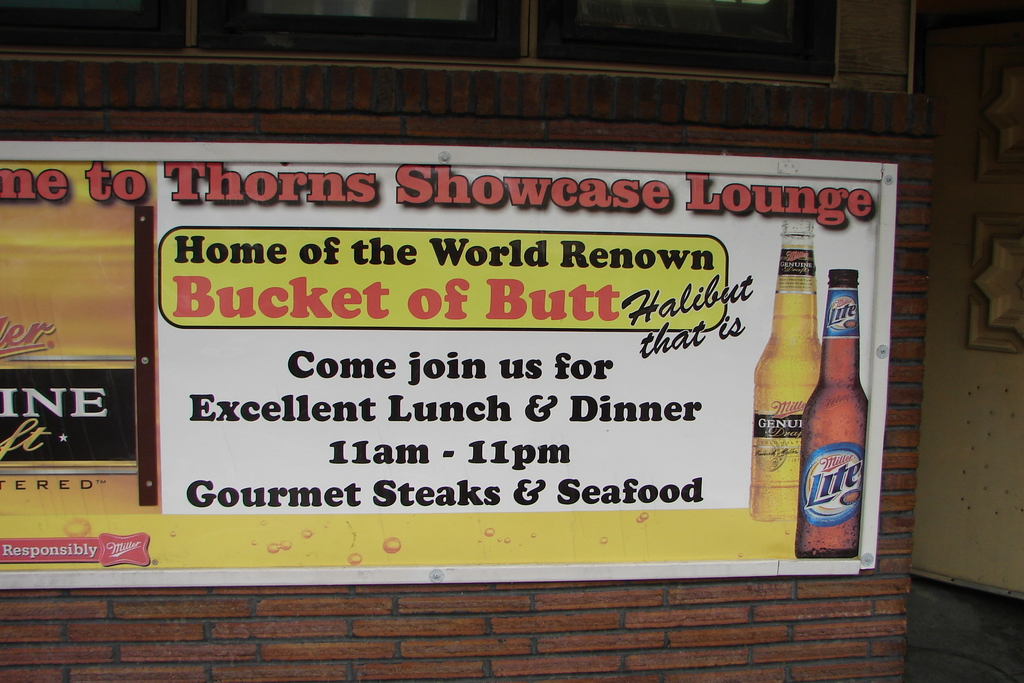What special does the Thorns Showcase Lounge offer? Thorns Showcase Lounge proudly offers 'Bucket of Butt Halibut,' a unique specialty dish that is highlighted on their colorful outdoor sign. This popular item promises a taste of local flavor, perfectly suited for seafood enthusiasts. 